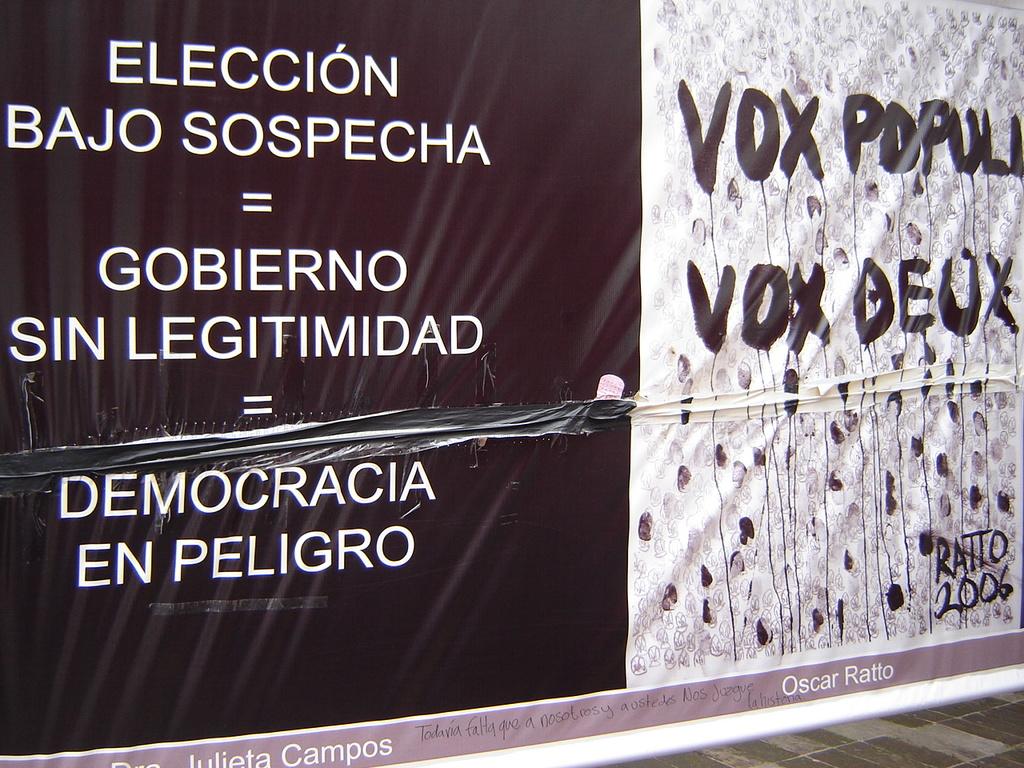What year is in the bottom corner of the painting?
Offer a very short reply. 2006. 